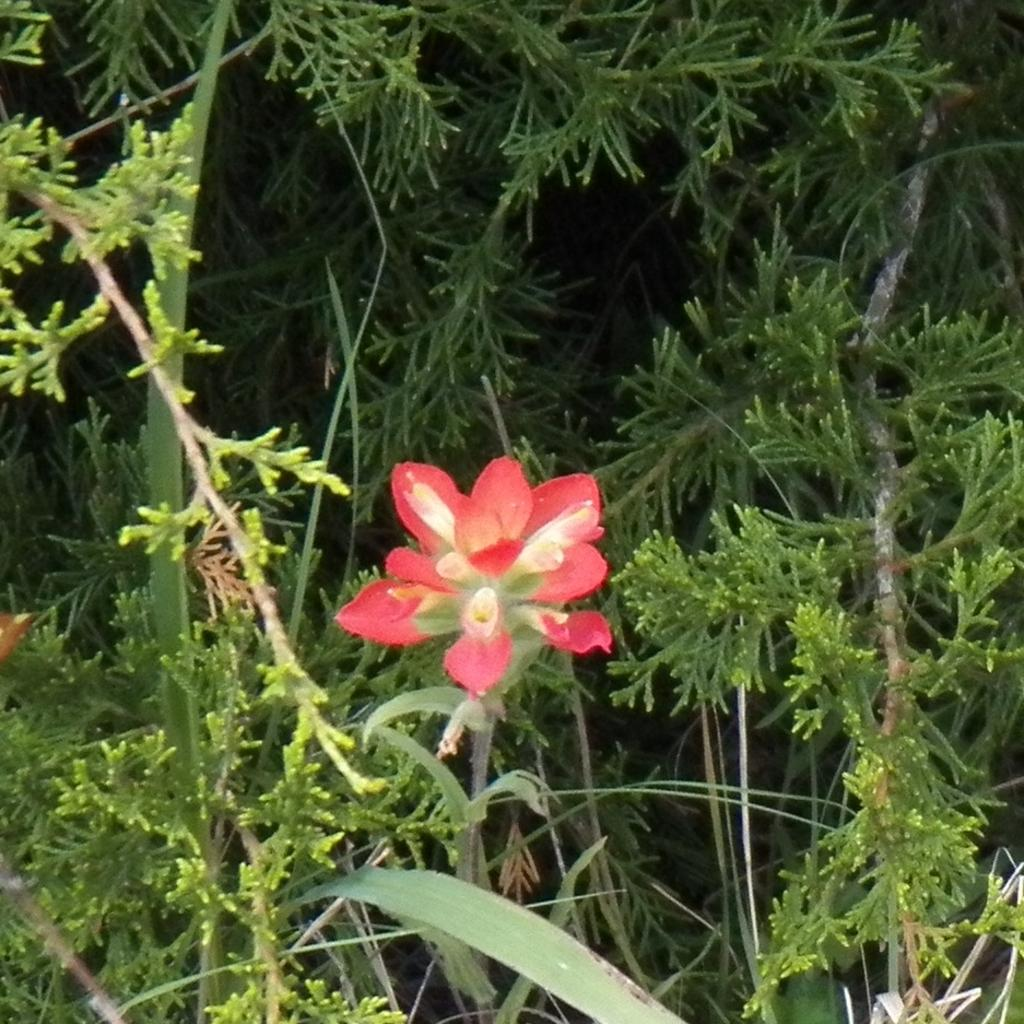What type of living organisms can be seen in the image? Plants can be seen in the image. Can you describe the main feature of the plants? There is a flower in the middle of the plants. How many snails can be seen crawling on the chairs in the image? There are no snails or chairs present in the image. What type of line is visible connecting the plants in the image? There is no line connecting the plants in the image. 